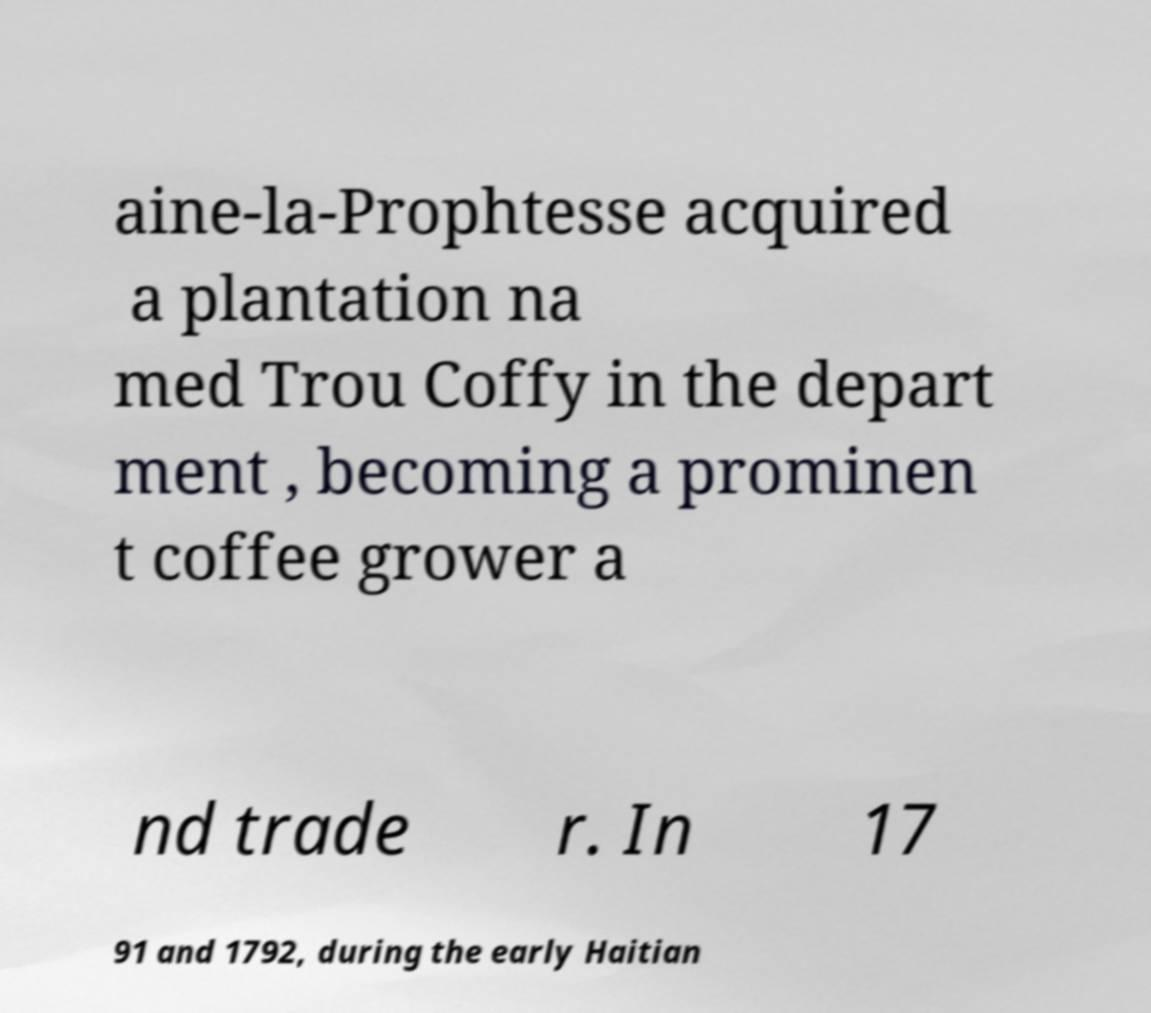I need the written content from this picture converted into text. Can you do that? aine-la-Prophtesse acquired a plantation na med Trou Coffy in the depart ment , becoming a prominen t coffee grower a nd trade r. In 17 91 and 1792, during the early Haitian 